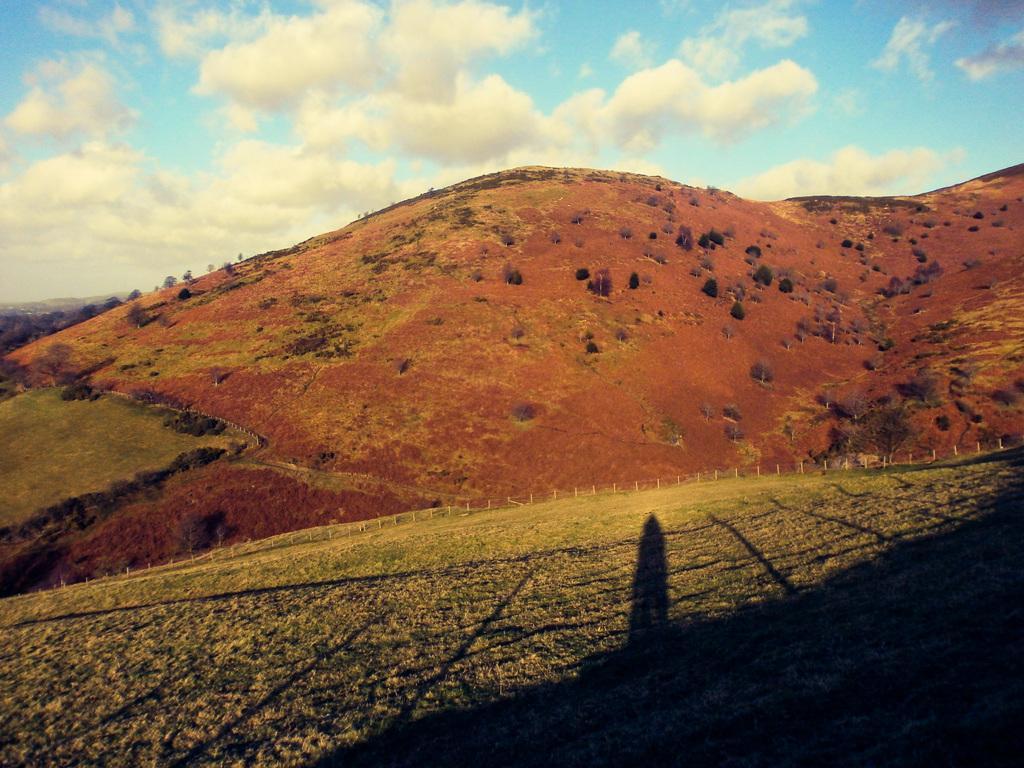Could you give a brief overview of what you see in this image? In the center of the image there are hills. At the bottom there is grass and we can see a fence. In the background there is sky. 